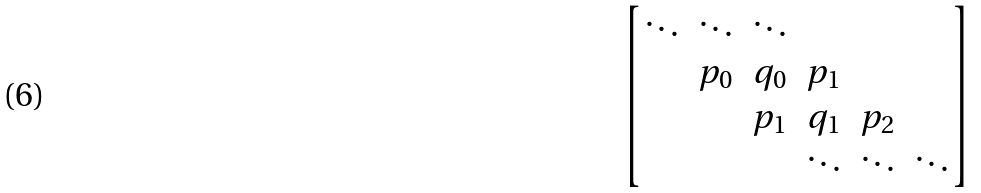Convert formula to latex. <formula><loc_0><loc_0><loc_500><loc_500>\begin{bmatrix} \ddots & \ddots & \ddots & & \\ & p _ { 0 } & q _ { 0 } & p _ { 1 } & \\ & & p _ { 1 } & q _ { 1 } & p _ { 2 } & \\ & & & \ddots & \ddots & \ddots \\ \end{bmatrix}</formula> 